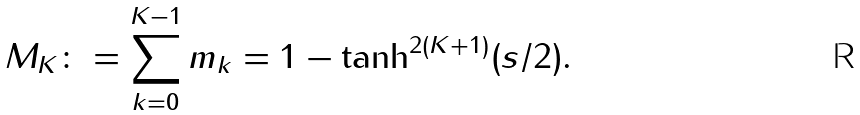Convert formula to latex. <formula><loc_0><loc_0><loc_500><loc_500>M _ { K } \colon = \sum _ { k = 0 } ^ { K - 1 } m _ { k } = 1 - \tanh ^ { 2 ( K + 1 ) } ( s / 2 ) .</formula> 